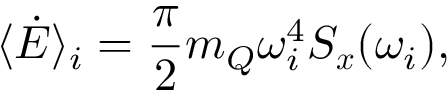Convert formula to latex. <formula><loc_0><loc_0><loc_500><loc_500>\langle \dot { E } \rangle _ { i } = \frac { \pi } { 2 } m _ { Q } \omega _ { i } ^ { 4 } S _ { x } ( \omega _ { i } ) ,</formula> 